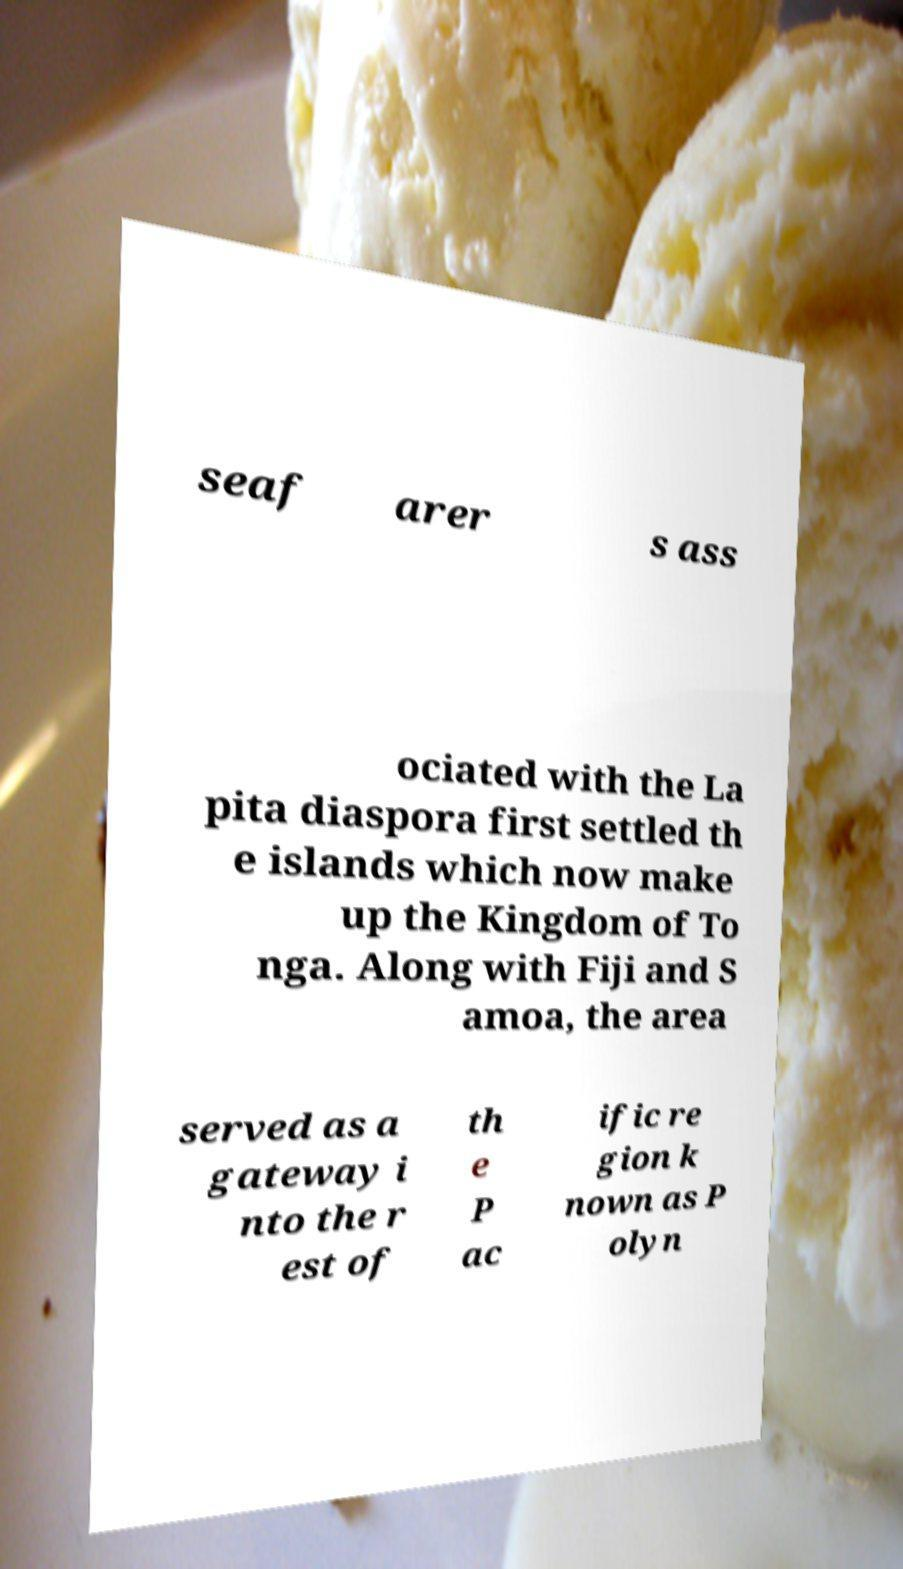I need the written content from this picture converted into text. Can you do that? seaf arer s ass ociated with the La pita diaspora first settled th e islands which now make up the Kingdom of To nga. Along with Fiji and S amoa, the area served as a gateway i nto the r est of th e P ac ific re gion k nown as P olyn 